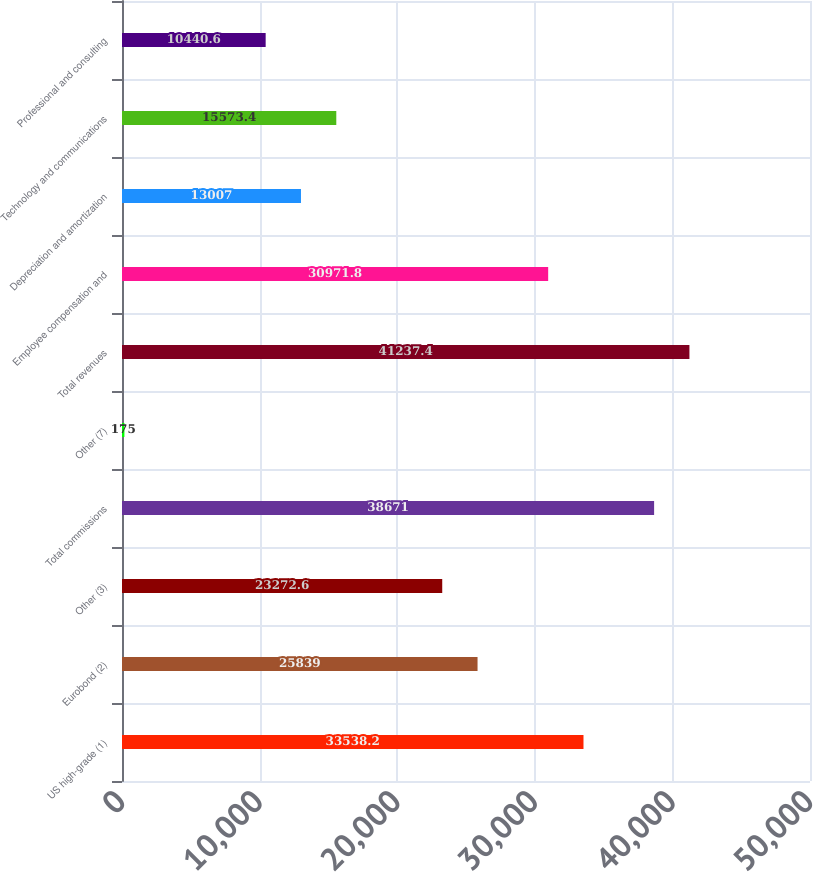Convert chart to OTSL. <chart><loc_0><loc_0><loc_500><loc_500><bar_chart><fcel>US high-grade (1)<fcel>Eurobond (2)<fcel>Other (3)<fcel>Total commissions<fcel>Other (7)<fcel>Total revenues<fcel>Employee compensation and<fcel>Depreciation and amortization<fcel>Technology and communications<fcel>Professional and consulting<nl><fcel>33538.2<fcel>25839<fcel>23272.6<fcel>38671<fcel>175<fcel>41237.4<fcel>30971.8<fcel>13007<fcel>15573.4<fcel>10440.6<nl></chart> 